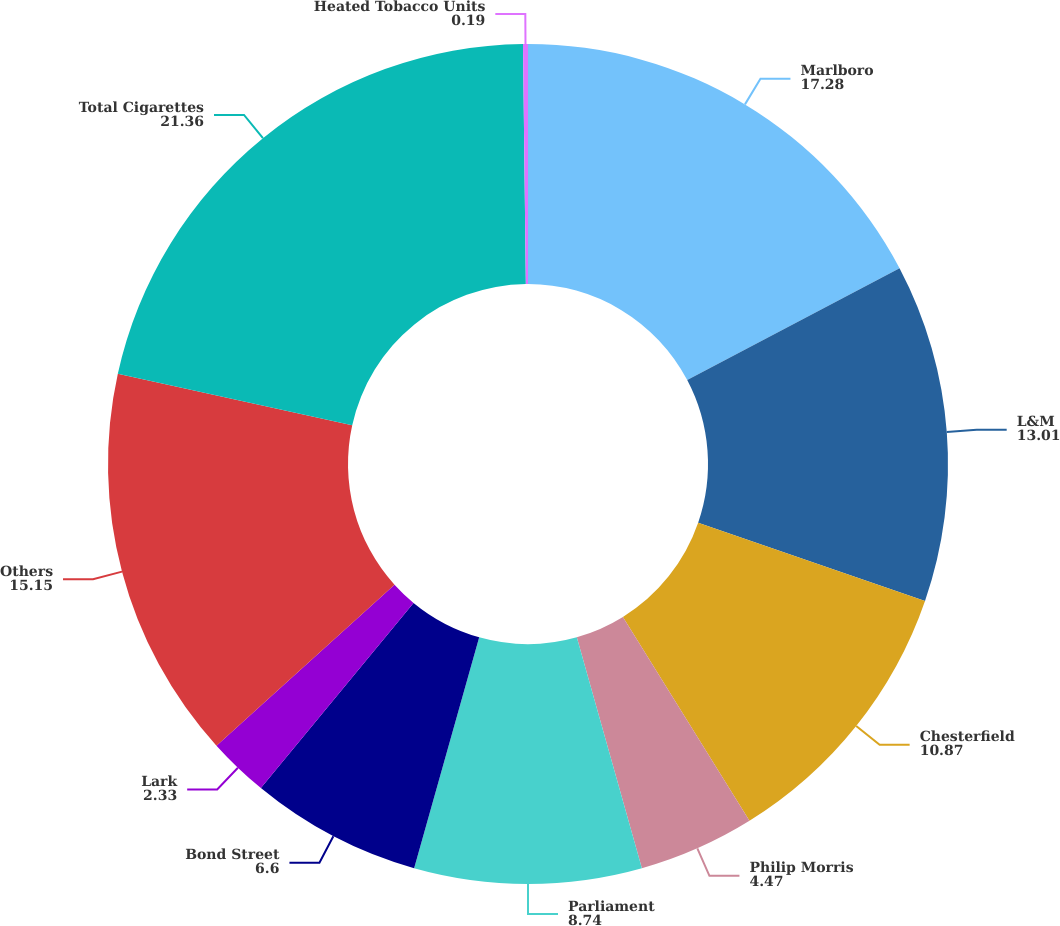<chart> <loc_0><loc_0><loc_500><loc_500><pie_chart><fcel>Marlboro<fcel>L&M<fcel>Chesterfield<fcel>Philip Morris<fcel>Parliament<fcel>Bond Street<fcel>Lark<fcel>Others<fcel>Total Cigarettes<fcel>Heated Tobacco Units<nl><fcel>17.28%<fcel>13.01%<fcel>10.87%<fcel>4.47%<fcel>8.74%<fcel>6.6%<fcel>2.33%<fcel>15.15%<fcel>21.36%<fcel>0.19%<nl></chart> 